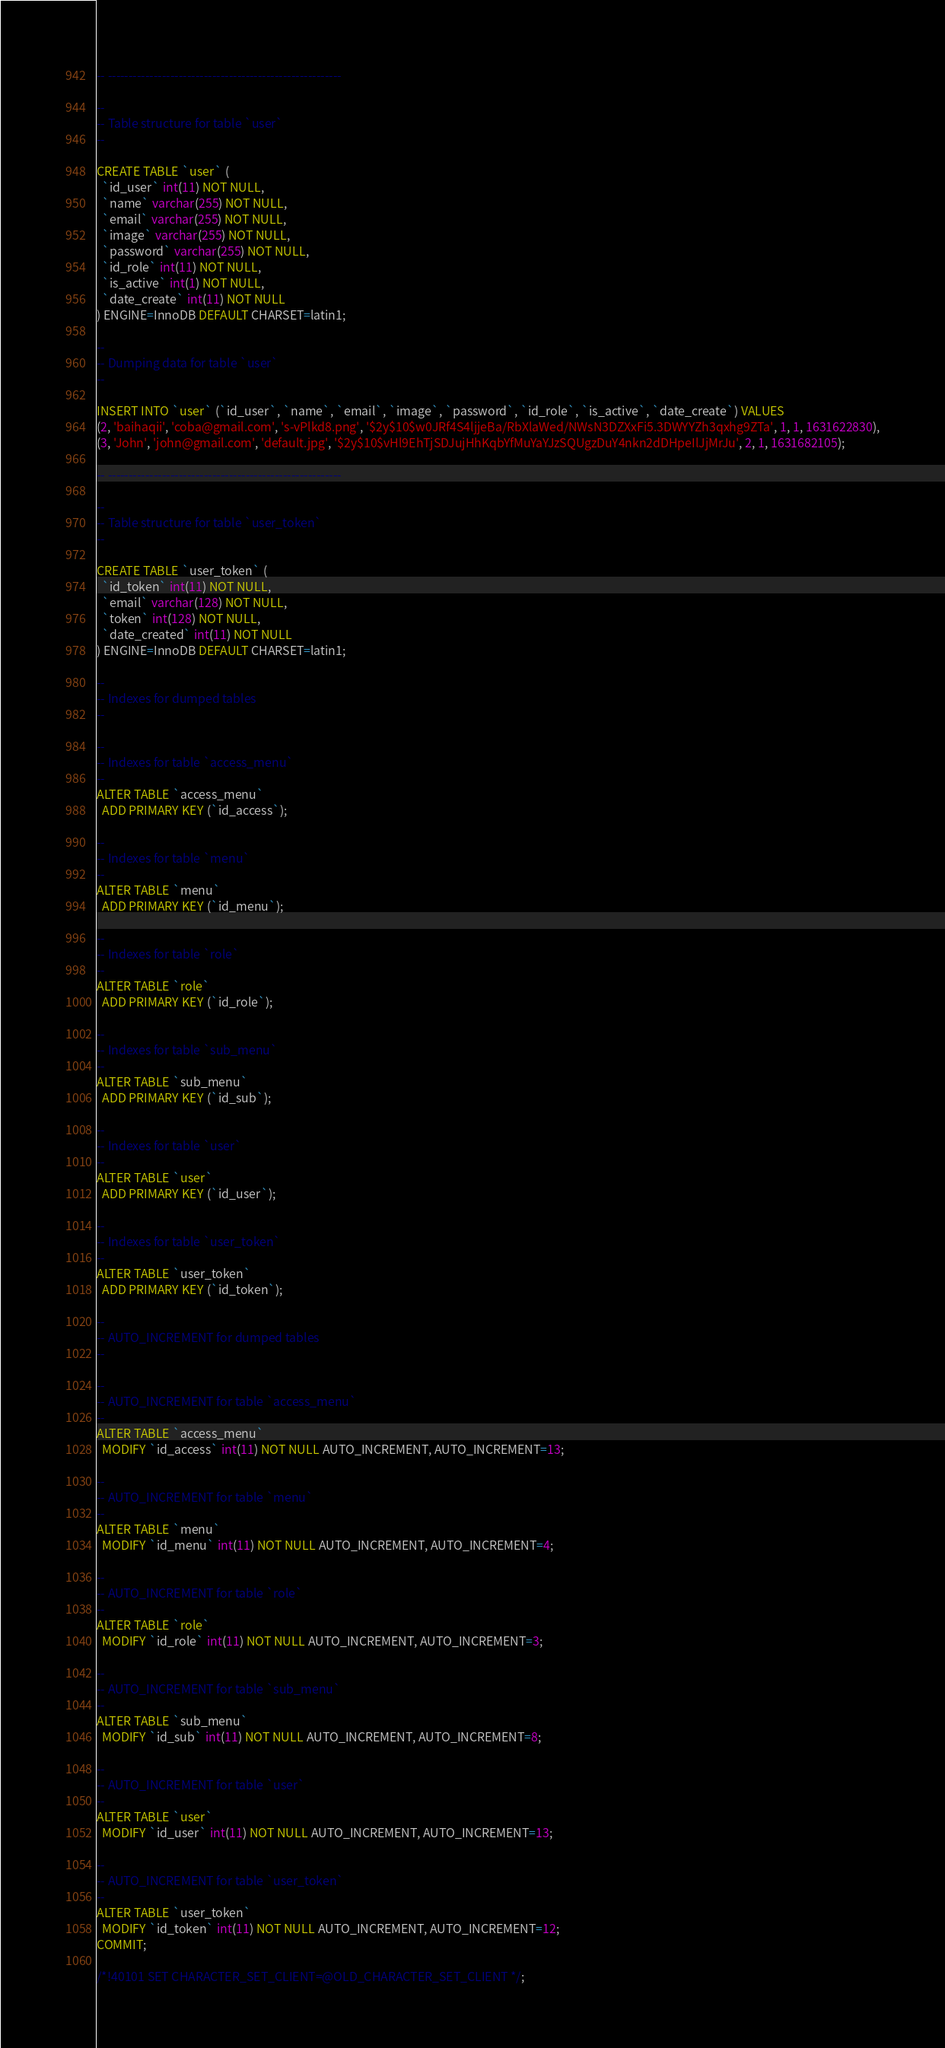Convert code to text. <code><loc_0><loc_0><loc_500><loc_500><_SQL_>-- --------------------------------------------------------

--
-- Table structure for table `user`
--

CREATE TABLE `user` (
  `id_user` int(11) NOT NULL,
  `name` varchar(255) NOT NULL,
  `email` varchar(255) NOT NULL,
  `image` varchar(255) NOT NULL,
  `password` varchar(255) NOT NULL,
  `id_role` int(11) NOT NULL,
  `is_active` int(1) NOT NULL,
  `date_create` int(11) NOT NULL
) ENGINE=InnoDB DEFAULT CHARSET=latin1;

--
-- Dumping data for table `user`
--

INSERT INTO `user` (`id_user`, `name`, `email`, `image`, `password`, `id_role`, `is_active`, `date_create`) VALUES
(2, 'baihaqii', 'coba@gmail.com', 's-vPlkd8.png', '$2y$10$w0JRf4S4ljjeBa/RbXlaWed/NWsN3DZXxFi5.3DWYYZh3qxhg9ZTa', 1, 1, 1631622830),
(3, 'John', 'john@gmail.com', 'default.jpg', '$2y$10$vHl9EhTjSDJujHhKqbYfMuYaYJzSQUgzDuY4nkn2dDHpeIlJjMrJu', 2, 1, 1631682105);

-- --------------------------------------------------------

--
-- Table structure for table `user_token`
--

CREATE TABLE `user_token` (
  `id_token` int(11) NOT NULL,
  `email` varchar(128) NOT NULL,
  `token` int(128) NOT NULL,
  `date_created` int(11) NOT NULL
) ENGINE=InnoDB DEFAULT CHARSET=latin1;

--
-- Indexes for dumped tables
--

--
-- Indexes for table `access_menu`
--
ALTER TABLE `access_menu`
  ADD PRIMARY KEY (`id_access`);

--
-- Indexes for table `menu`
--
ALTER TABLE `menu`
  ADD PRIMARY KEY (`id_menu`);

--
-- Indexes for table `role`
--
ALTER TABLE `role`
  ADD PRIMARY KEY (`id_role`);

--
-- Indexes for table `sub_menu`
--
ALTER TABLE `sub_menu`
  ADD PRIMARY KEY (`id_sub`);

--
-- Indexes for table `user`
--
ALTER TABLE `user`
  ADD PRIMARY KEY (`id_user`);

--
-- Indexes for table `user_token`
--
ALTER TABLE `user_token`
  ADD PRIMARY KEY (`id_token`);

--
-- AUTO_INCREMENT for dumped tables
--

--
-- AUTO_INCREMENT for table `access_menu`
--
ALTER TABLE `access_menu`
  MODIFY `id_access` int(11) NOT NULL AUTO_INCREMENT, AUTO_INCREMENT=13;

--
-- AUTO_INCREMENT for table `menu`
--
ALTER TABLE `menu`
  MODIFY `id_menu` int(11) NOT NULL AUTO_INCREMENT, AUTO_INCREMENT=4;

--
-- AUTO_INCREMENT for table `role`
--
ALTER TABLE `role`
  MODIFY `id_role` int(11) NOT NULL AUTO_INCREMENT, AUTO_INCREMENT=3;

--
-- AUTO_INCREMENT for table `sub_menu`
--
ALTER TABLE `sub_menu`
  MODIFY `id_sub` int(11) NOT NULL AUTO_INCREMENT, AUTO_INCREMENT=8;

--
-- AUTO_INCREMENT for table `user`
--
ALTER TABLE `user`
  MODIFY `id_user` int(11) NOT NULL AUTO_INCREMENT, AUTO_INCREMENT=13;

--
-- AUTO_INCREMENT for table `user_token`
--
ALTER TABLE `user_token`
  MODIFY `id_token` int(11) NOT NULL AUTO_INCREMENT, AUTO_INCREMENT=12;
COMMIT;

/*!40101 SET CHARACTER_SET_CLIENT=@OLD_CHARACTER_SET_CLIENT */;</code> 